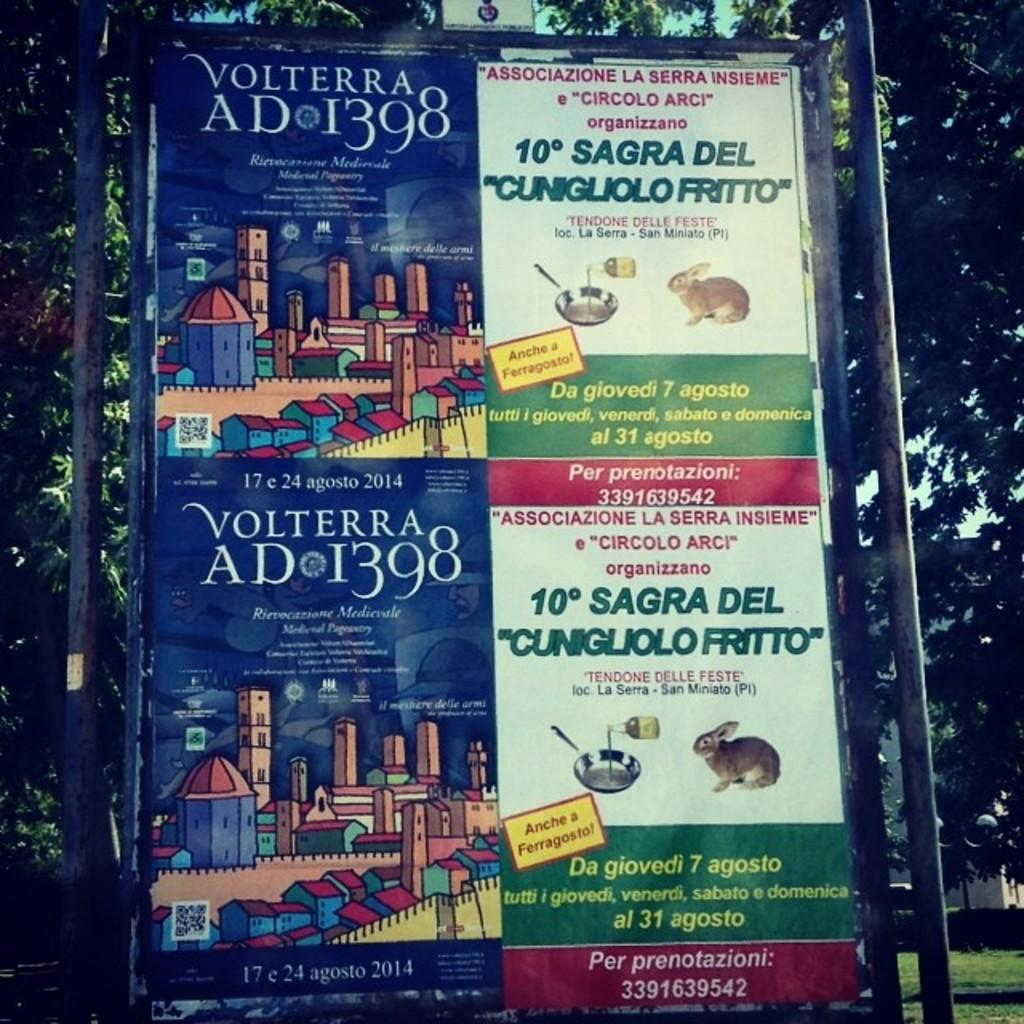Provide a one-sentence caption for the provided image. An Italian advertisement previews an event in Volterra and a festival of a fried rabbit. 